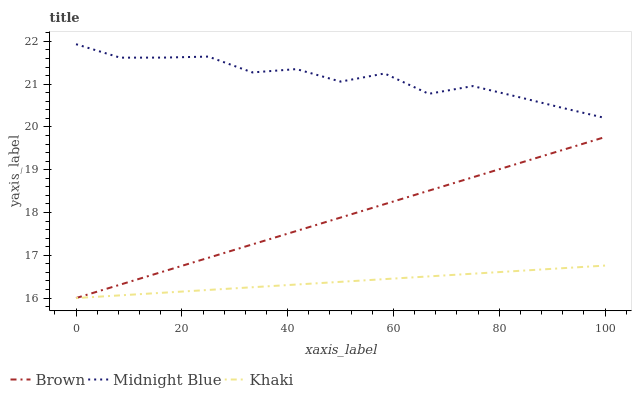Does Khaki have the minimum area under the curve?
Answer yes or no. Yes. Does Midnight Blue have the maximum area under the curve?
Answer yes or no. Yes. Does Midnight Blue have the minimum area under the curve?
Answer yes or no. No. Does Khaki have the maximum area under the curve?
Answer yes or no. No. Is Brown the smoothest?
Answer yes or no. Yes. Is Midnight Blue the roughest?
Answer yes or no. Yes. Is Khaki the smoothest?
Answer yes or no. No. Is Khaki the roughest?
Answer yes or no. No. Does Midnight Blue have the lowest value?
Answer yes or no. No. Does Midnight Blue have the highest value?
Answer yes or no. Yes. Does Khaki have the highest value?
Answer yes or no. No. Is Brown less than Midnight Blue?
Answer yes or no. Yes. Is Midnight Blue greater than Brown?
Answer yes or no. Yes. Does Khaki intersect Brown?
Answer yes or no. Yes. Is Khaki less than Brown?
Answer yes or no. No. Is Khaki greater than Brown?
Answer yes or no. No. Does Brown intersect Midnight Blue?
Answer yes or no. No. 